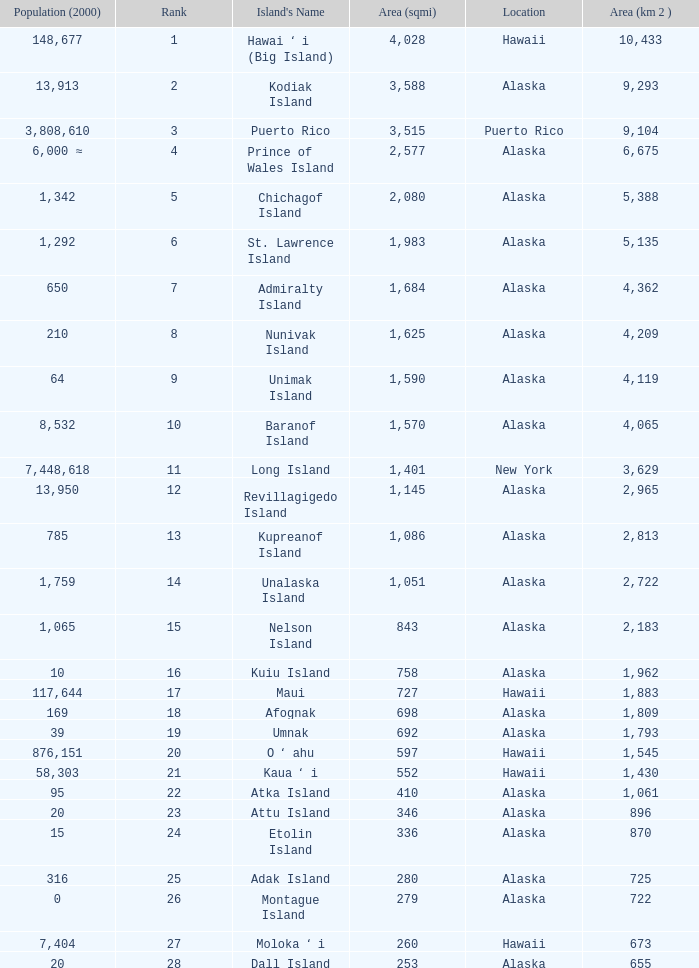What is the largest area in Alaska with a population of 39 and rank over 19? None. 